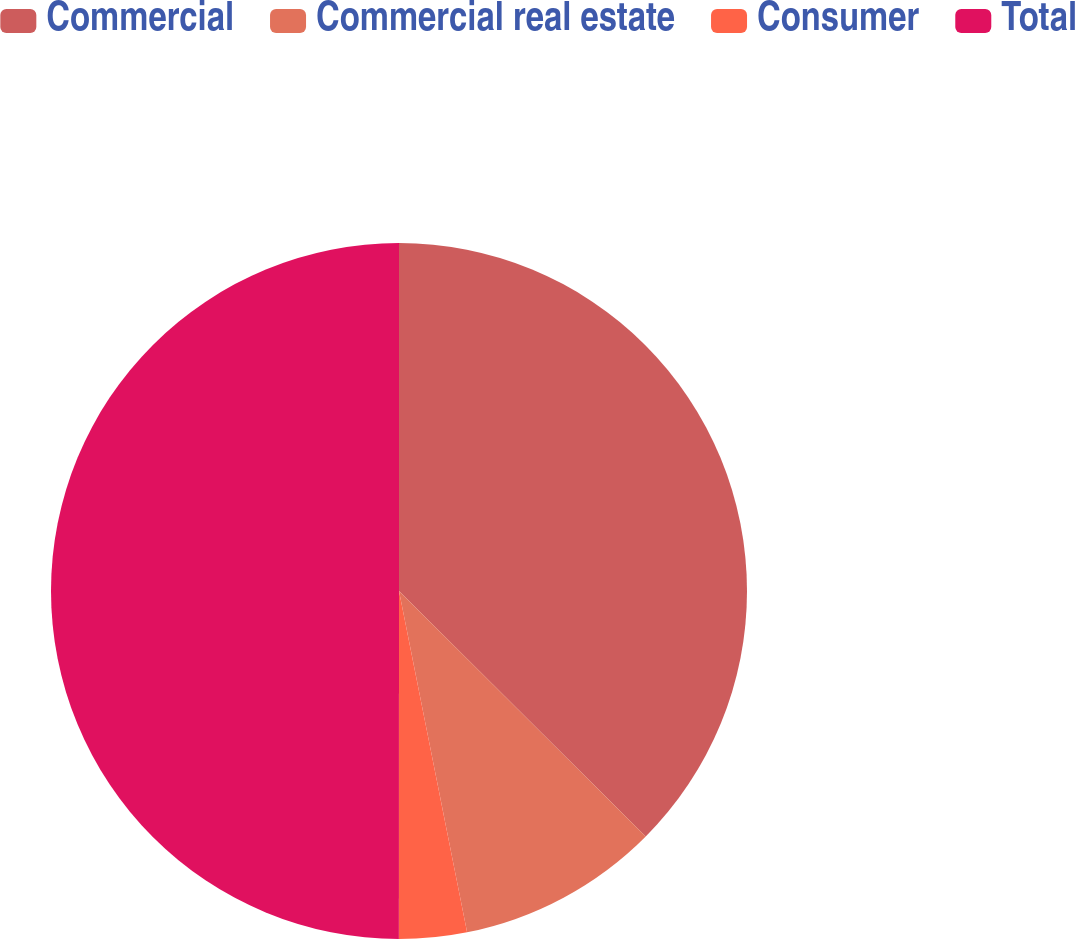Convert chart. <chart><loc_0><loc_0><loc_500><loc_500><pie_chart><fcel>Commercial<fcel>Commercial real estate<fcel>Consumer<fcel>Total<nl><fcel>37.46%<fcel>9.41%<fcel>3.14%<fcel>50.0%<nl></chart> 